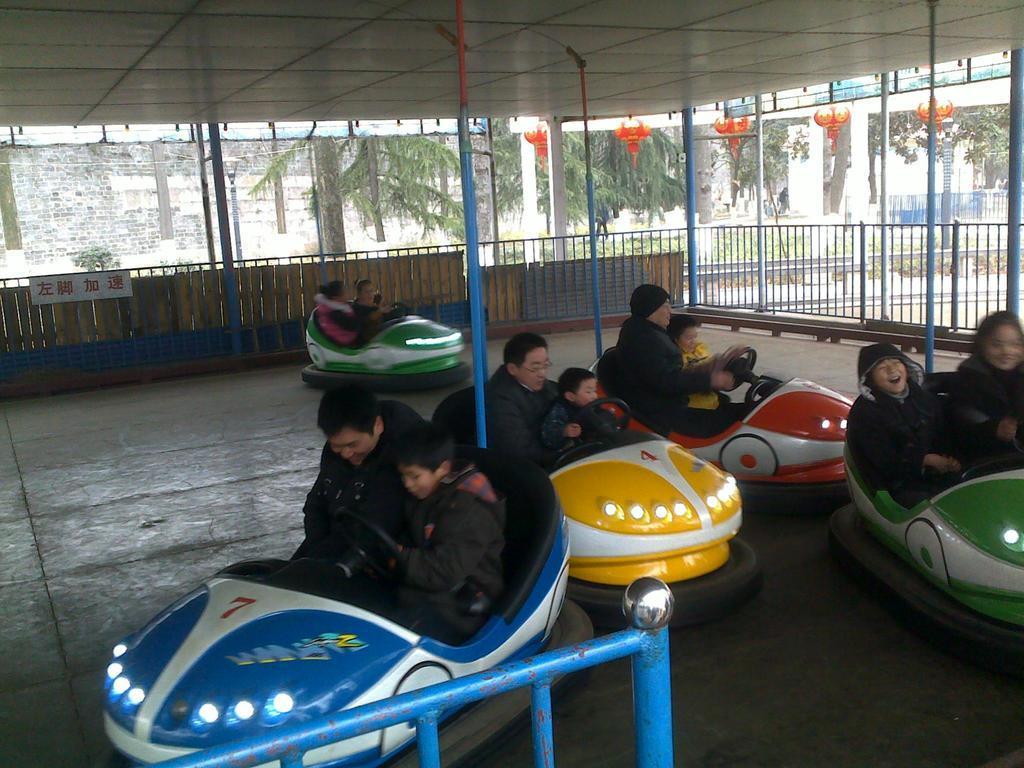Describe this image in one or two sentences. In the image we can see there are many people wearing clothes and they are sitting in the car. This is an electric toy car, this is a pole, fence and trees. 